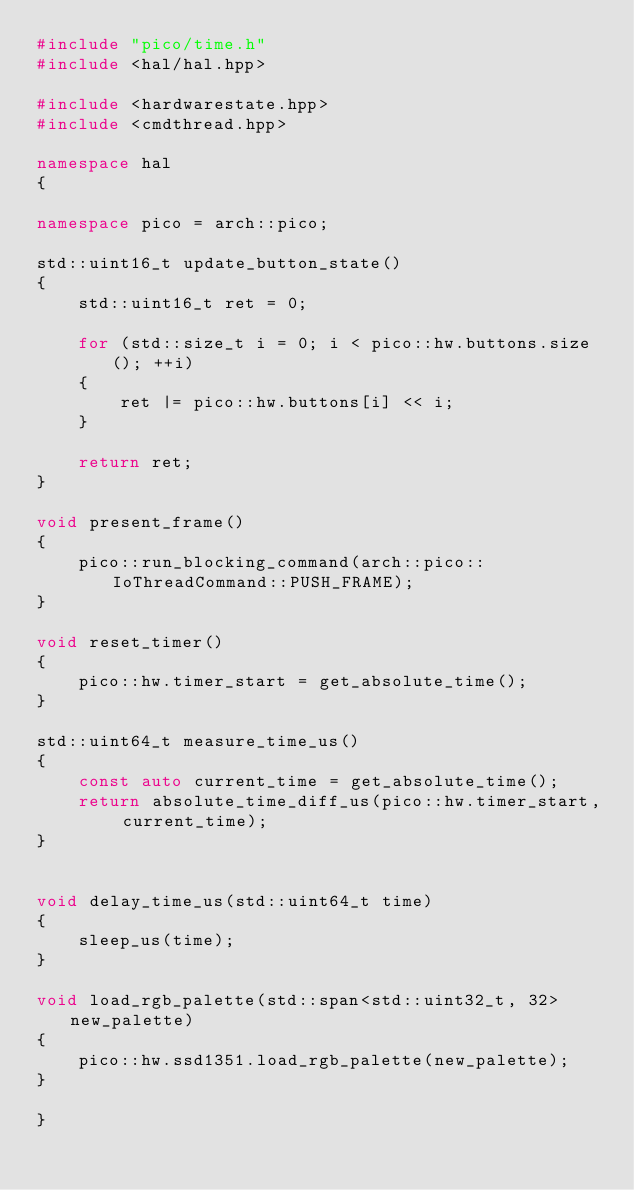Convert code to text. <code><loc_0><loc_0><loc_500><loc_500><_C++_>#include "pico/time.h"
#include <hal/hal.hpp>

#include <hardwarestate.hpp>
#include <cmdthread.hpp>

namespace hal
{

namespace pico = arch::pico;

std::uint16_t update_button_state()
{
    std::uint16_t ret = 0;

    for (std::size_t i = 0; i < pico::hw.buttons.size(); ++i)
    {
        ret |= pico::hw.buttons[i] << i;
    }

    return ret;
}

void present_frame()
{
    pico::run_blocking_command(arch::pico::IoThreadCommand::PUSH_FRAME);
}

void reset_timer()
{
    pico::hw.timer_start = get_absolute_time();
}

std::uint64_t measure_time_us()
{
    const auto current_time = get_absolute_time();
    return absolute_time_diff_us(pico::hw.timer_start, current_time);
}


void delay_time_us(std::uint64_t time)
{
    sleep_us(time);
}

void load_rgb_palette(std::span<std::uint32_t, 32> new_palette)
{
    pico::hw.ssd1351.load_rgb_palette(new_palette);
}

}</code> 